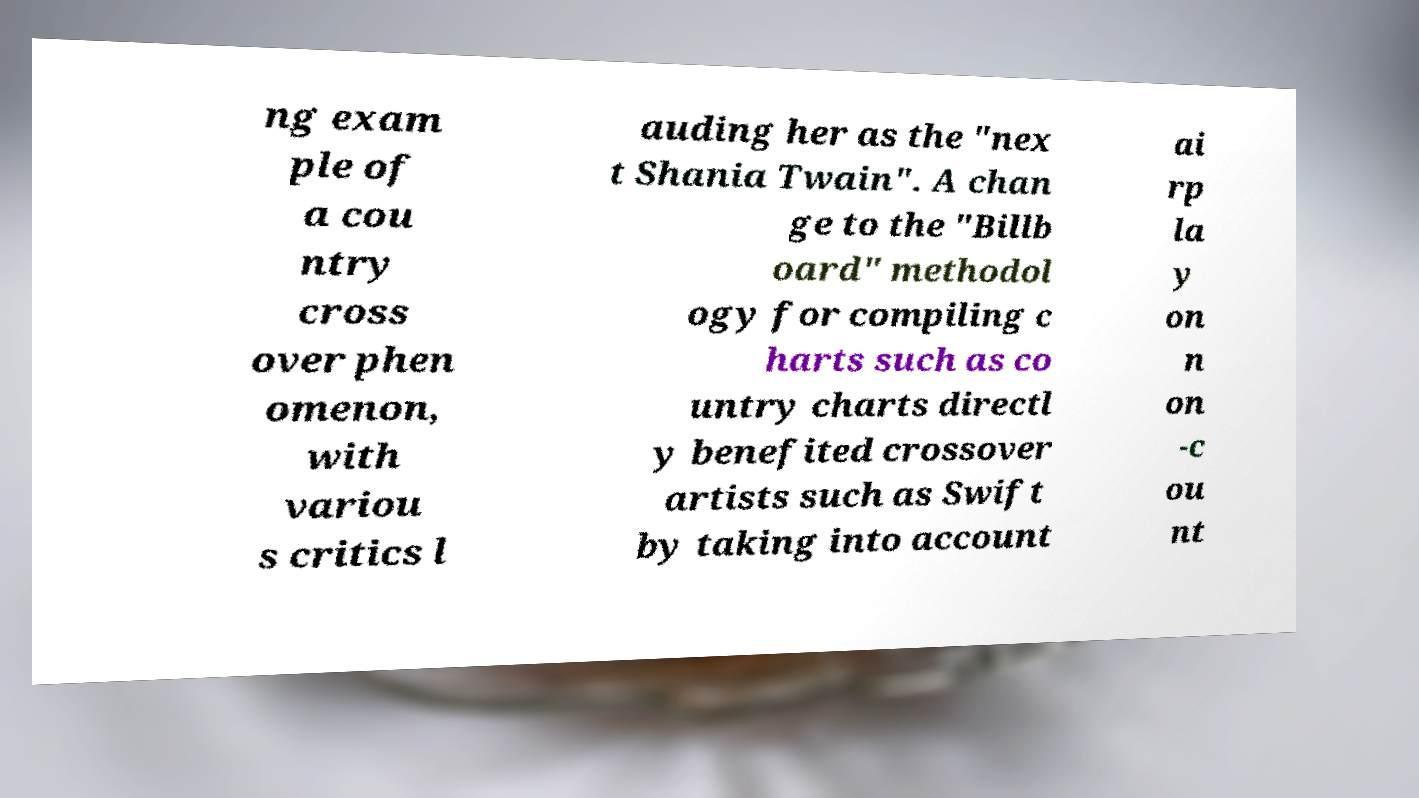There's text embedded in this image that I need extracted. Can you transcribe it verbatim? ng exam ple of a cou ntry cross over phen omenon, with variou s critics l auding her as the "nex t Shania Twain". A chan ge to the "Billb oard" methodol ogy for compiling c harts such as co untry charts directl y benefited crossover artists such as Swift by taking into account ai rp la y on n on -c ou nt 